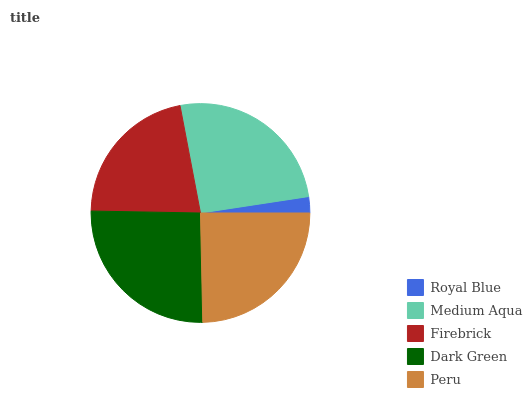Is Royal Blue the minimum?
Answer yes or no. Yes. Is Dark Green the maximum?
Answer yes or no. Yes. Is Medium Aqua the minimum?
Answer yes or no. No. Is Medium Aqua the maximum?
Answer yes or no. No. Is Medium Aqua greater than Royal Blue?
Answer yes or no. Yes. Is Royal Blue less than Medium Aqua?
Answer yes or no. Yes. Is Royal Blue greater than Medium Aqua?
Answer yes or no. No. Is Medium Aqua less than Royal Blue?
Answer yes or no. No. Is Peru the high median?
Answer yes or no. Yes. Is Peru the low median?
Answer yes or no. Yes. Is Royal Blue the high median?
Answer yes or no. No. Is Medium Aqua the low median?
Answer yes or no. No. 